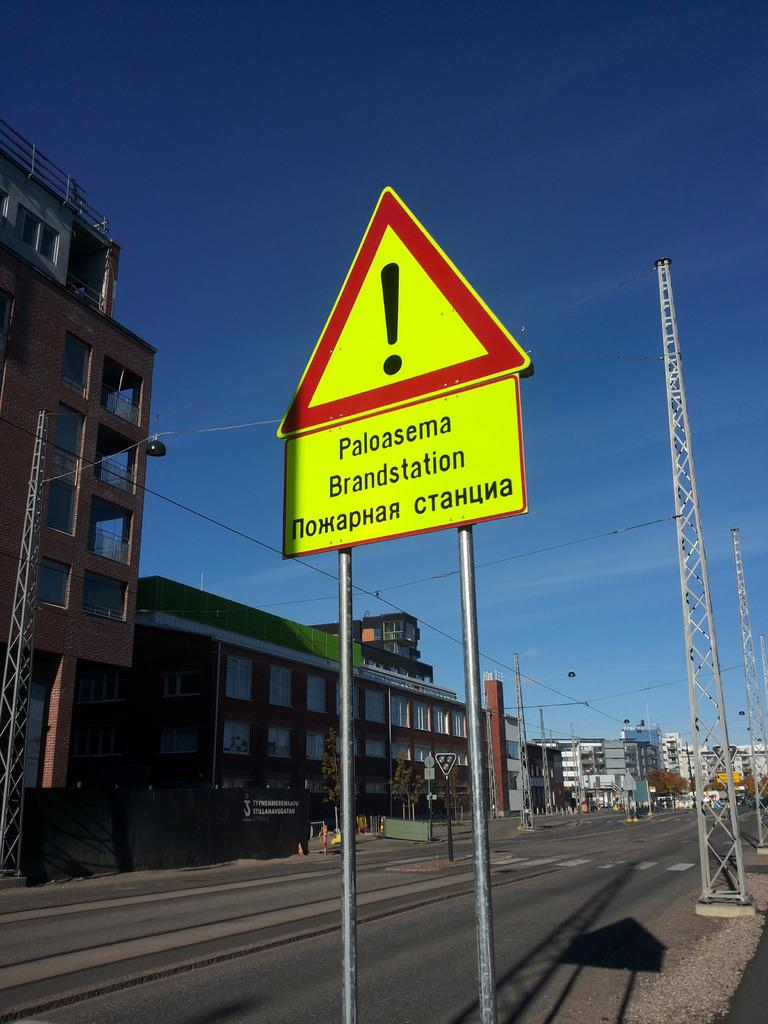Provide a one-sentence caption for the provided image. Sign that says Paloasema brandstation on the side of the road. 